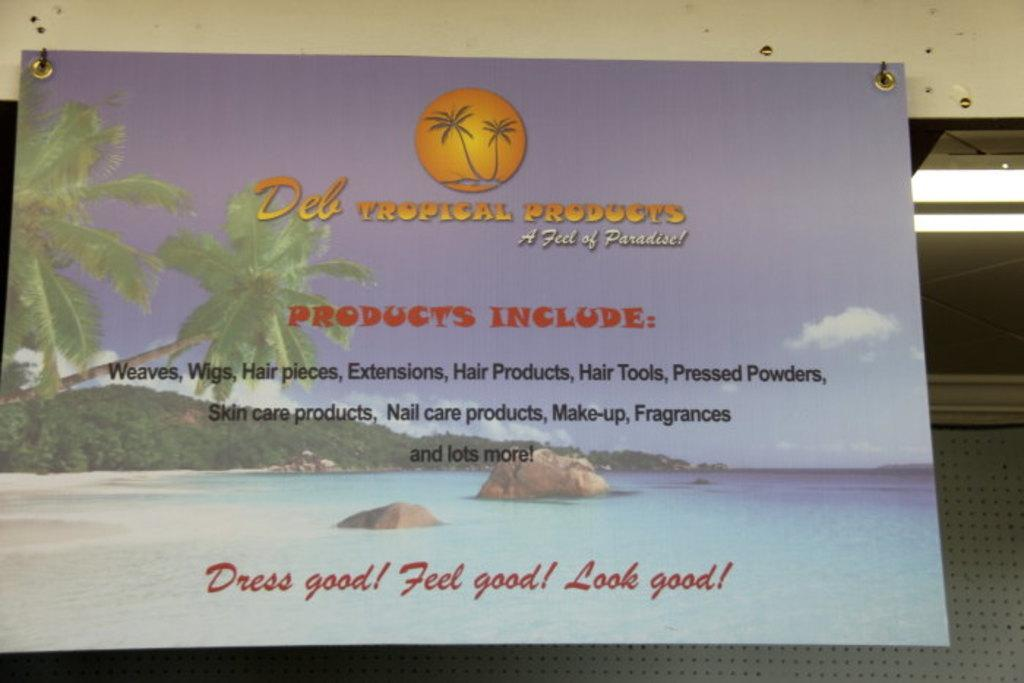What is hanging on the wall in the image? There is a banner with text and images in the image. How is the banner attached to the wall? The banner is attached to the wall. What can be seen on the right side of the image? There are lights on the right side of the image. What type of object is visible in the background of the image? There is a metal object in the background of the image. How many stars can be seen in the image? There are no stars visible in the image. What part of the banner is made of yoke? The banner does not contain any yoke; it is made of text and images. 